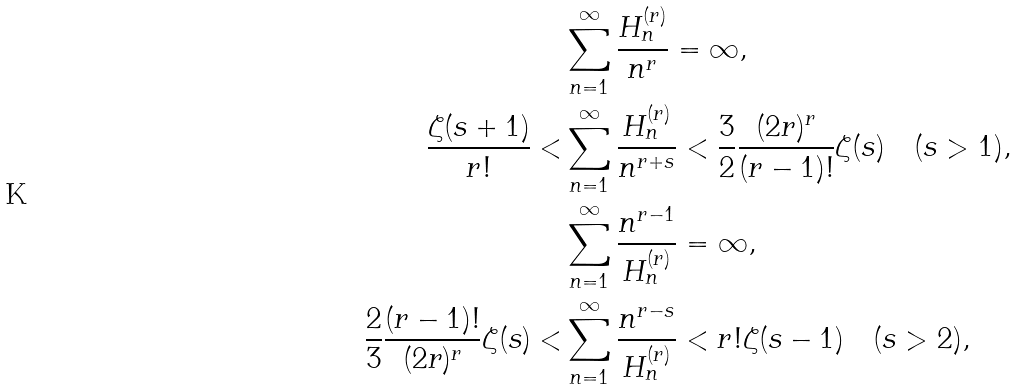Convert formula to latex. <formula><loc_0><loc_0><loc_500><loc_500>& \sum _ { n = 1 } ^ { \infty } \frac { H _ { n } ^ { ( r ) } } { n ^ { r } } = \infty , \\ \frac { \zeta ( s + 1 ) } { r ! } < & \sum _ { n = 1 } ^ { \infty } \frac { H _ { n } ^ { ( r ) } } { n ^ { r + s } } < \frac { 3 } { 2 } \frac { ( 2 r ) ^ { r } } { ( r - 1 ) ! } \zeta ( s ) \quad ( s > 1 ) , \\ & \sum _ { n = 1 } ^ { \infty } \frac { n ^ { r - 1 } } { H _ { n } ^ { ( r ) } } = \infty , \\ \frac { 2 } { 3 } \frac { ( r - 1 ) ! } { ( 2 r ) ^ { r } } \zeta ( s ) < & \sum _ { n = 1 } ^ { \infty } \frac { n ^ { r - s } } { H _ { n } ^ { ( r ) } } < r ! \zeta ( s - 1 ) \quad ( s > 2 ) ,</formula> 